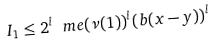<formula> <loc_0><loc_0><loc_500><loc_500>I _ { 1 } \leq 2 ^ { l } \ m e ( \nu ( 1 ) ) ^ { l } ( b ( x - y ) ) ^ { l }</formula> 